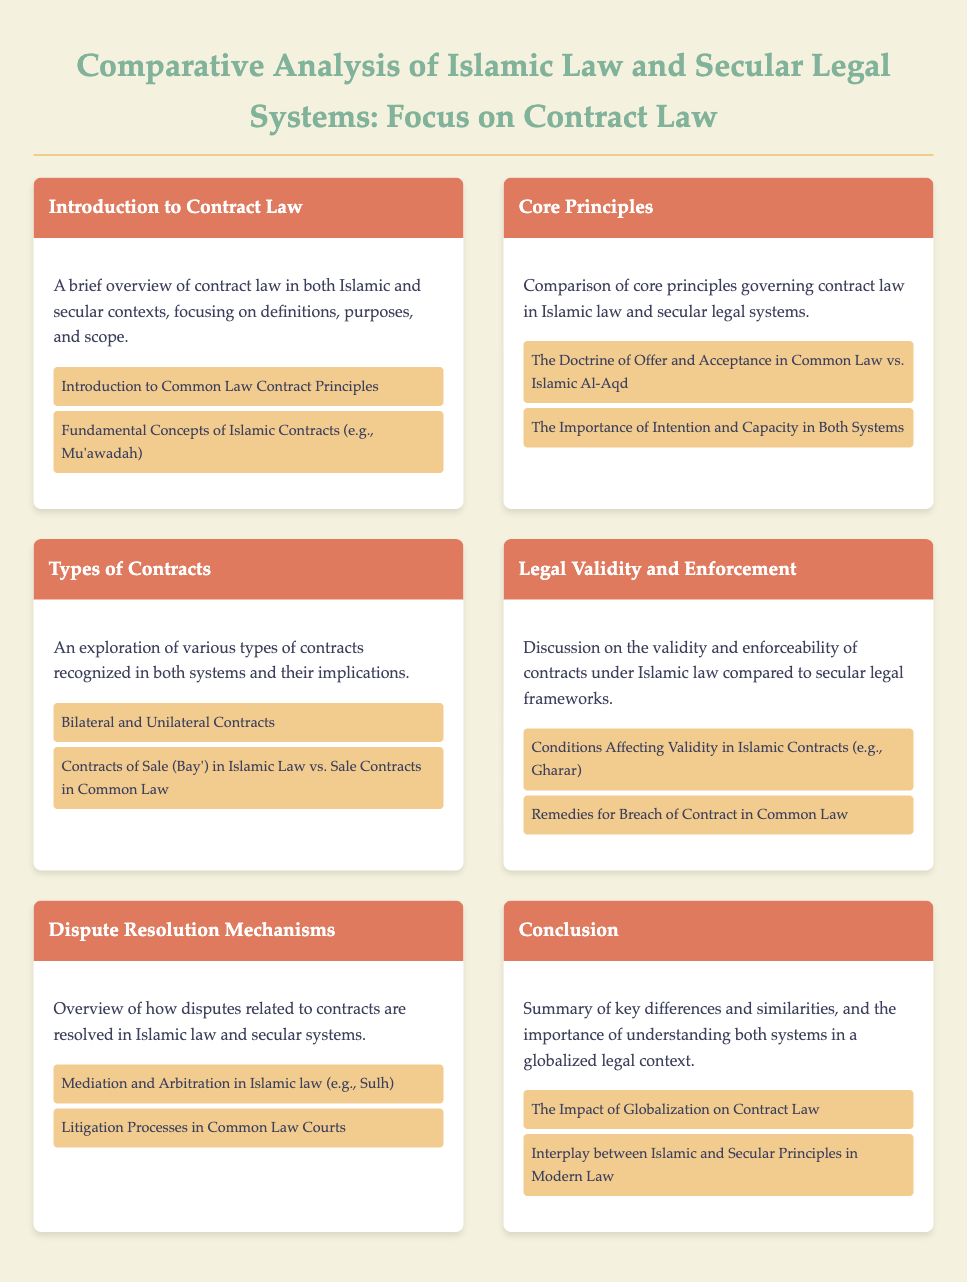What is the title of the document? The title of the document is displayed prominently at the top of the rendered page, summarizing its focus.
Answer: Comparative Analysis of Islamic Law and Secular Legal Systems: Focus on Contract Law How many main sections are in the menu? The menu contains multiple sections, each addressing a specific aspect of contract law in both systems.
Answer: Six What is one example of a contract type mentioned in the document? The document lists examples of contract types under the "Types of Contracts" section.
Answer: Bilateral and Unilateral Contracts What concept affects the validity of contracts in Islamic law? The section on Legal Validity and Enforcement discusses conditions affecting contract validity in Islamic law.
Answer: Gharar What is one method of dispute resolution mentioned in Islamic law? The section on Dispute Resolution Mechanisms provides examples of how disputes are resolved under Islamic law.
Answer: Mediation Which principle is critical in both Islamic and common law? The "Core Principles" section highlights important legal principles that are relevant in both systems.
Answer: Intention and Capacity 